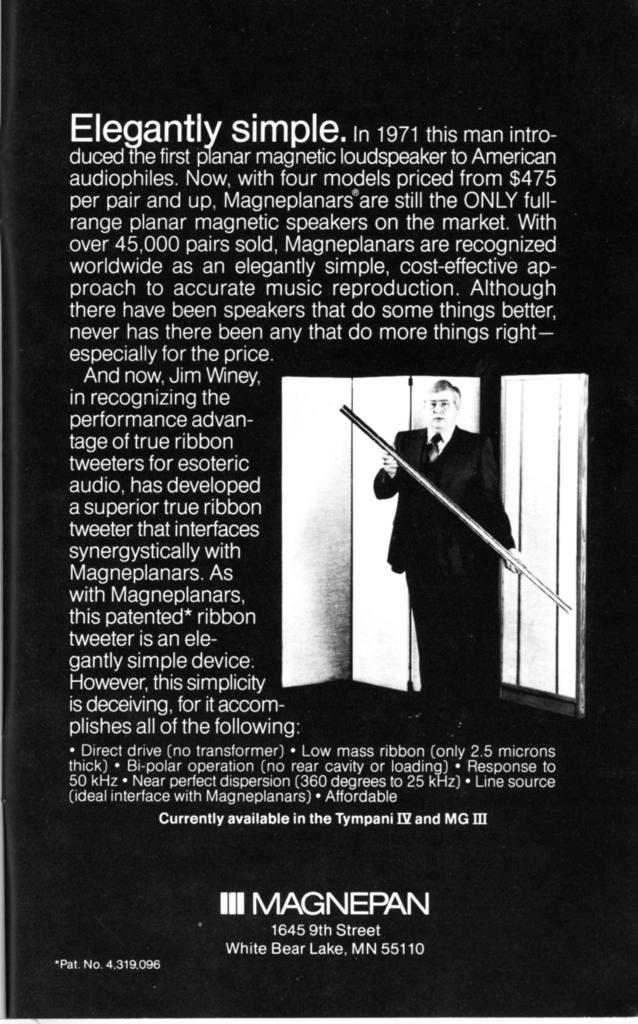What is featured on the poster in the image? There is a poster in the image, and it has text on it. Can you describe the photograph in the image? The photograph in the image features a person who is standing and wearing clothes. What is the person in the photograph holding in their hands? The person in the photograph is holding an object in their hands. What type of oil can be seen dripping from the poster in the image? There is no oil present in the image, and the poster does not appear to be dripping anything. 